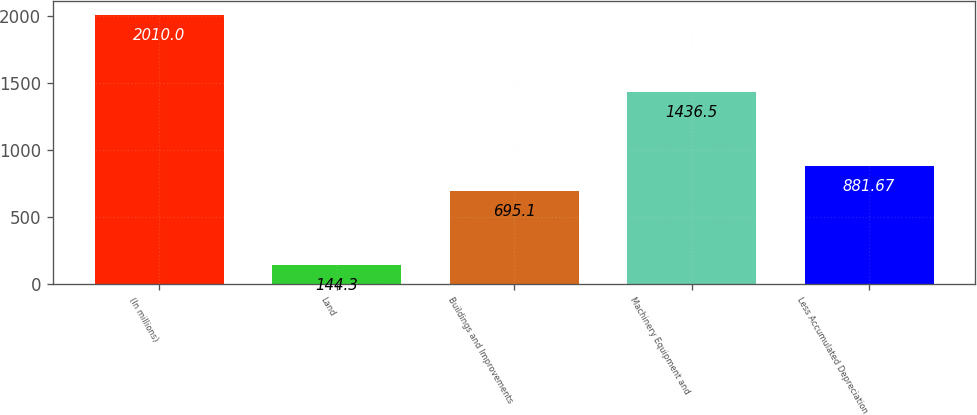Convert chart to OTSL. <chart><loc_0><loc_0><loc_500><loc_500><bar_chart><fcel>(In millions)<fcel>Land<fcel>Buildings and Improvements<fcel>Machinery Equipment and<fcel>Less Accumulated Depreciation<nl><fcel>2010<fcel>144.3<fcel>695.1<fcel>1436.5<fcel>881.67<nl></chart> 